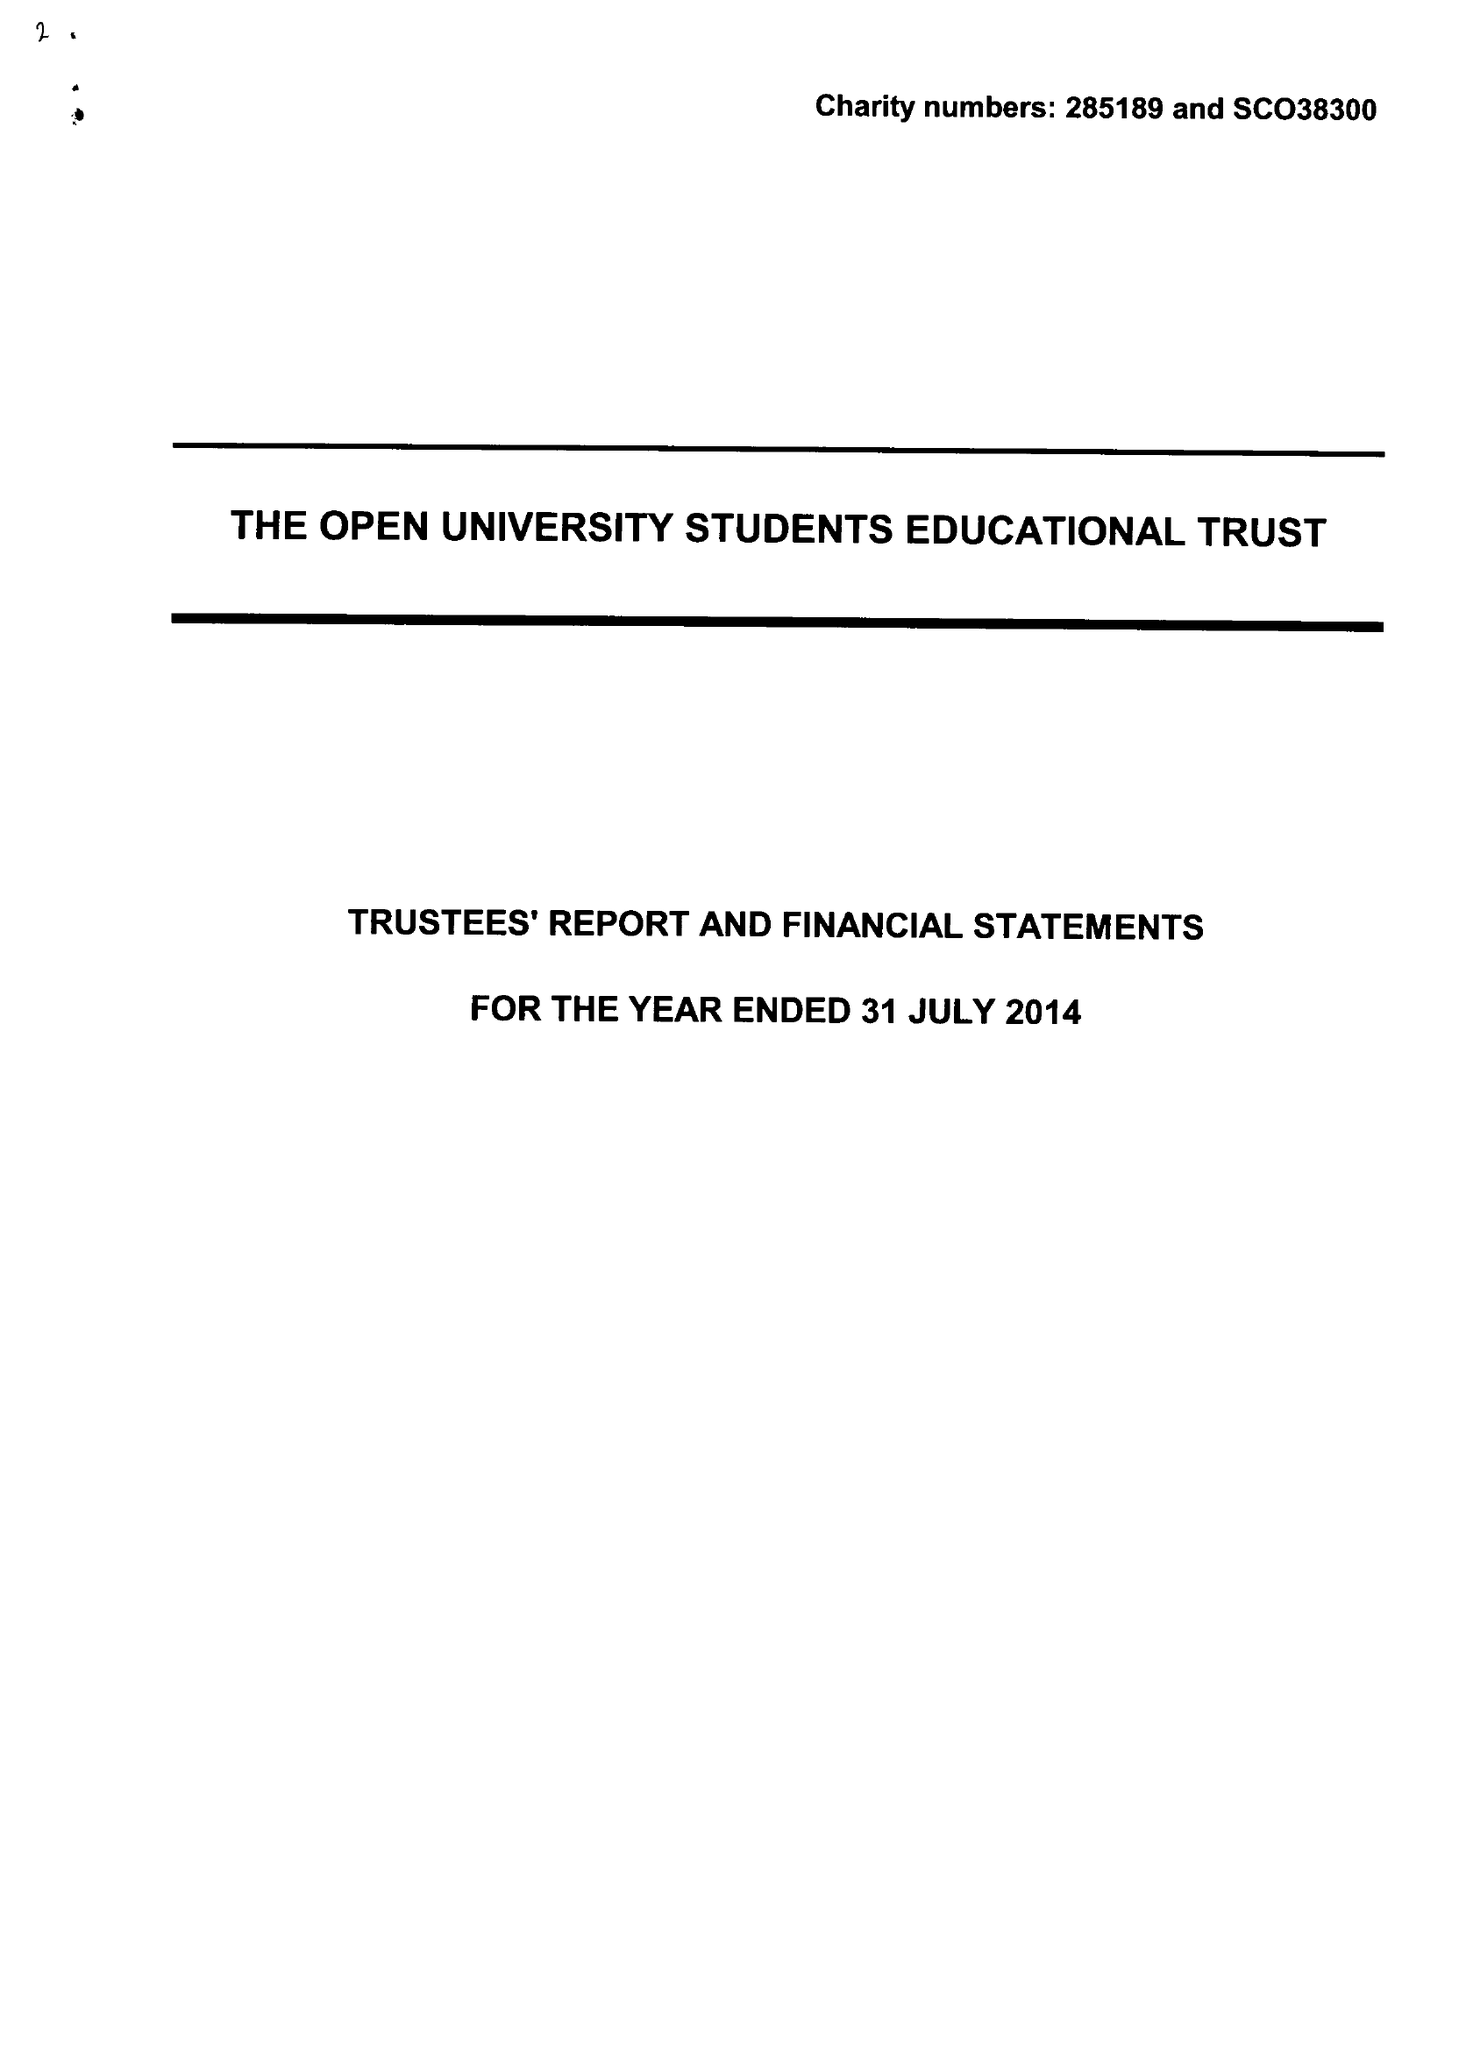What is the value for the address__postcode?
Answer the question using a single word or phrase. MK7 6BE 